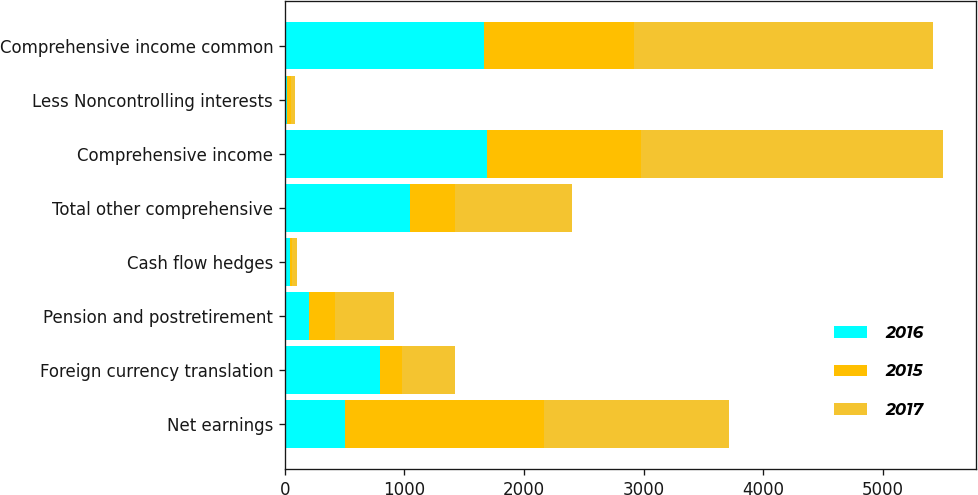Convert chart. <chart><loc_0><loc_0><loc_500><loc_500><stacked_bar_chart><ecel><fcel>Net earnings<fcel>Foreign currency translation<fcel>Pension and postretirement<fcel>Cash flow hedges<fcel>Total other comprehensive<fcel>Comprehensive income<fcel>Less Noncontrolling interests<fcel>Comprehensive income common<nl><fcel>2016<fcel>500<fcel>794<fcel>206<fcel>43<fcel>1043<fcel>1690<fcel>22<fcel>1668<nl><fcel>2015<fcel>1664<fcel>188<fcel>210<fcel>18<fcel>380<fcel>1284<fcel>31<fcel>1253<nl><fcel>2017<fcel>1550<fcel>441<fcel>500<fcel>37<fcel>978<fcel>2528<fcel>30<fcel>2498<nl></chart> 